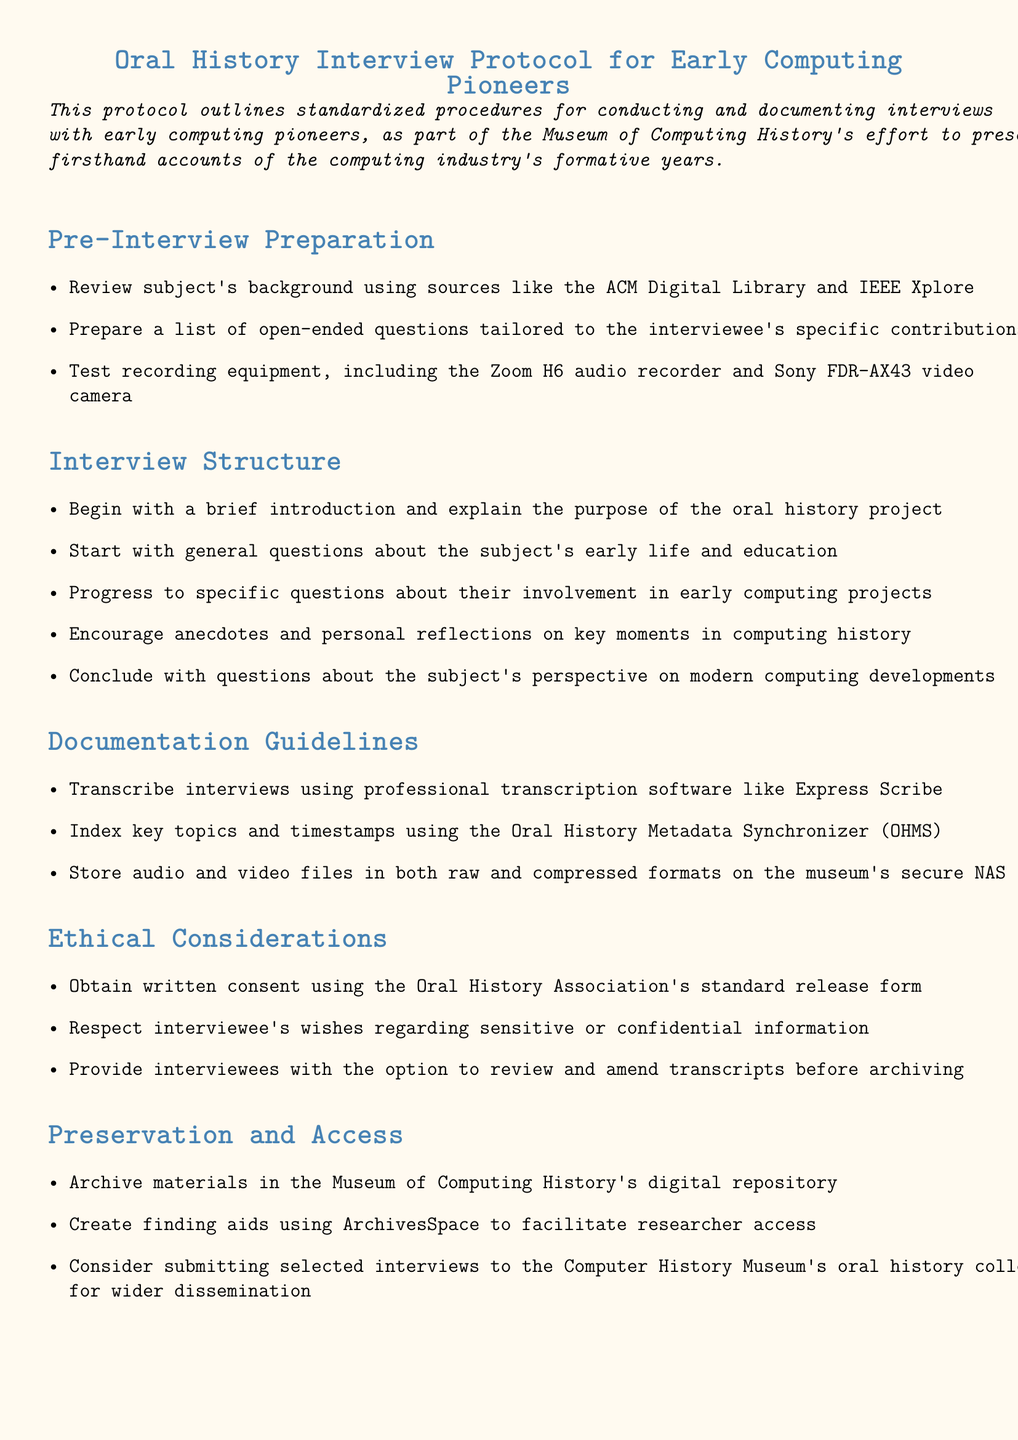What is the title of the document? The title of the document is stated at the beginning, detailing the oral history interview protocol for early computing pioneers.
Answer: Oral History Interview Protocol for Early Computing Pioneers How many sections are in the document? The document consists of five distinct sections outlining different protocols and guidelines.
Answer: Five What software is suggested for transcribing interviews? The document mentions professional transcription software that is specifically recommended for transcribing interviews.
Answer: Express Scribe What type of equipment should be tested before the interview? The document advises preparing and testing specific equipment that will be used during the interviews.
Answer: Recording equipment What is required to obtain from interviewees before conducting the interview? The document lists a crucial ethical step that must be taken to comply with legal and organizational standards prior to conducting interviews.
Answer: Written consent What platform is mentioned for creating finding aids? The document specifies a particular platform that facilitates researcher access by allowing the creation of finding aids.
Answer: ArchivesSpace What should be indexed alongside interview transcripts? The document outlines the importance of organizing specific information to enhance the accessibility of interview materials.
Answer: Key topics and timestamps What aspect of modern computing is addressed in the interview's conclusion? The document specifies a topic that interviewees are encouraged to reflect on, which relates to contemporary developments in their field.
Answer: Their perspective on modern computing developments 